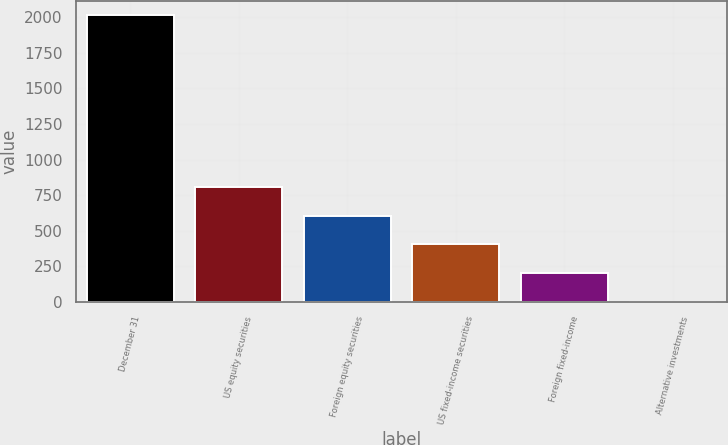Convert chart to OTSL. <chart><loc_0><loc_0><loc_500><loc_500><bar_chart><fcel>December 31<fcel>US equity securities<fcel>Foreign equity securities<fcel>US fixed-income securities<fcel>Foreign fixed-income<fcel>Alternative investments<nl><fcel>2013<fcel>806.4<fcel>605.3<fcel>404.2<fcel>203.1<fcel>2<nl></chart> 